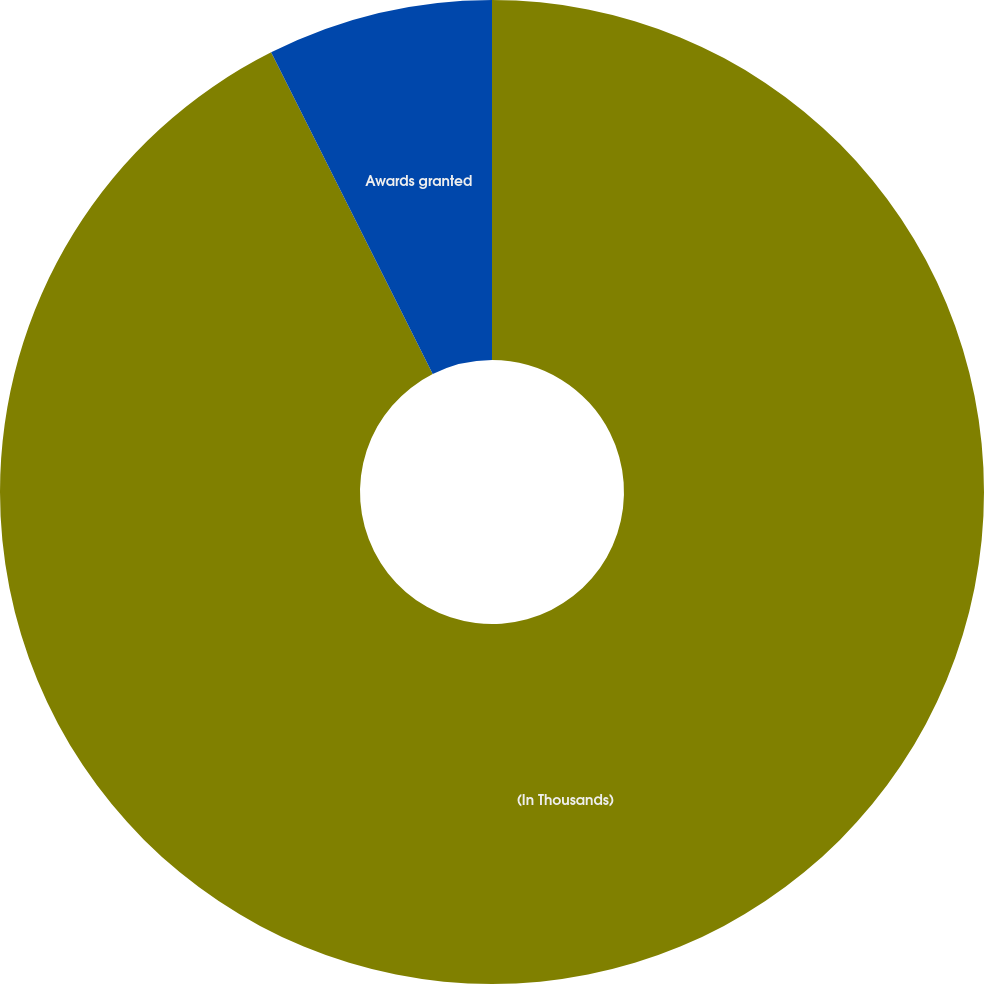Convert chart. <chart><loc_0><loc_0><loc_500><loc_500><pie_chart><fcel>(In Thousands)<fcel>Awards granted<nl><fcel>92.59%<fcel>7.41%<nl></chart> 